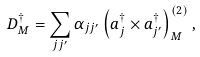Convert formula to latex. <formula><loc_0><loc_0><loc_500><loc_500>D ^ { \dagger } _ { M } = \sum _ { j j ^ { \prime } } \alpha _ { j j ^ { \prime } } \left ( a ^ { \dagger } _ { j } \times a ^ { \dagger } _ { j ^ { \prime } } \right ) ^ { ( 2 ) } _ { M } ,</formula> 